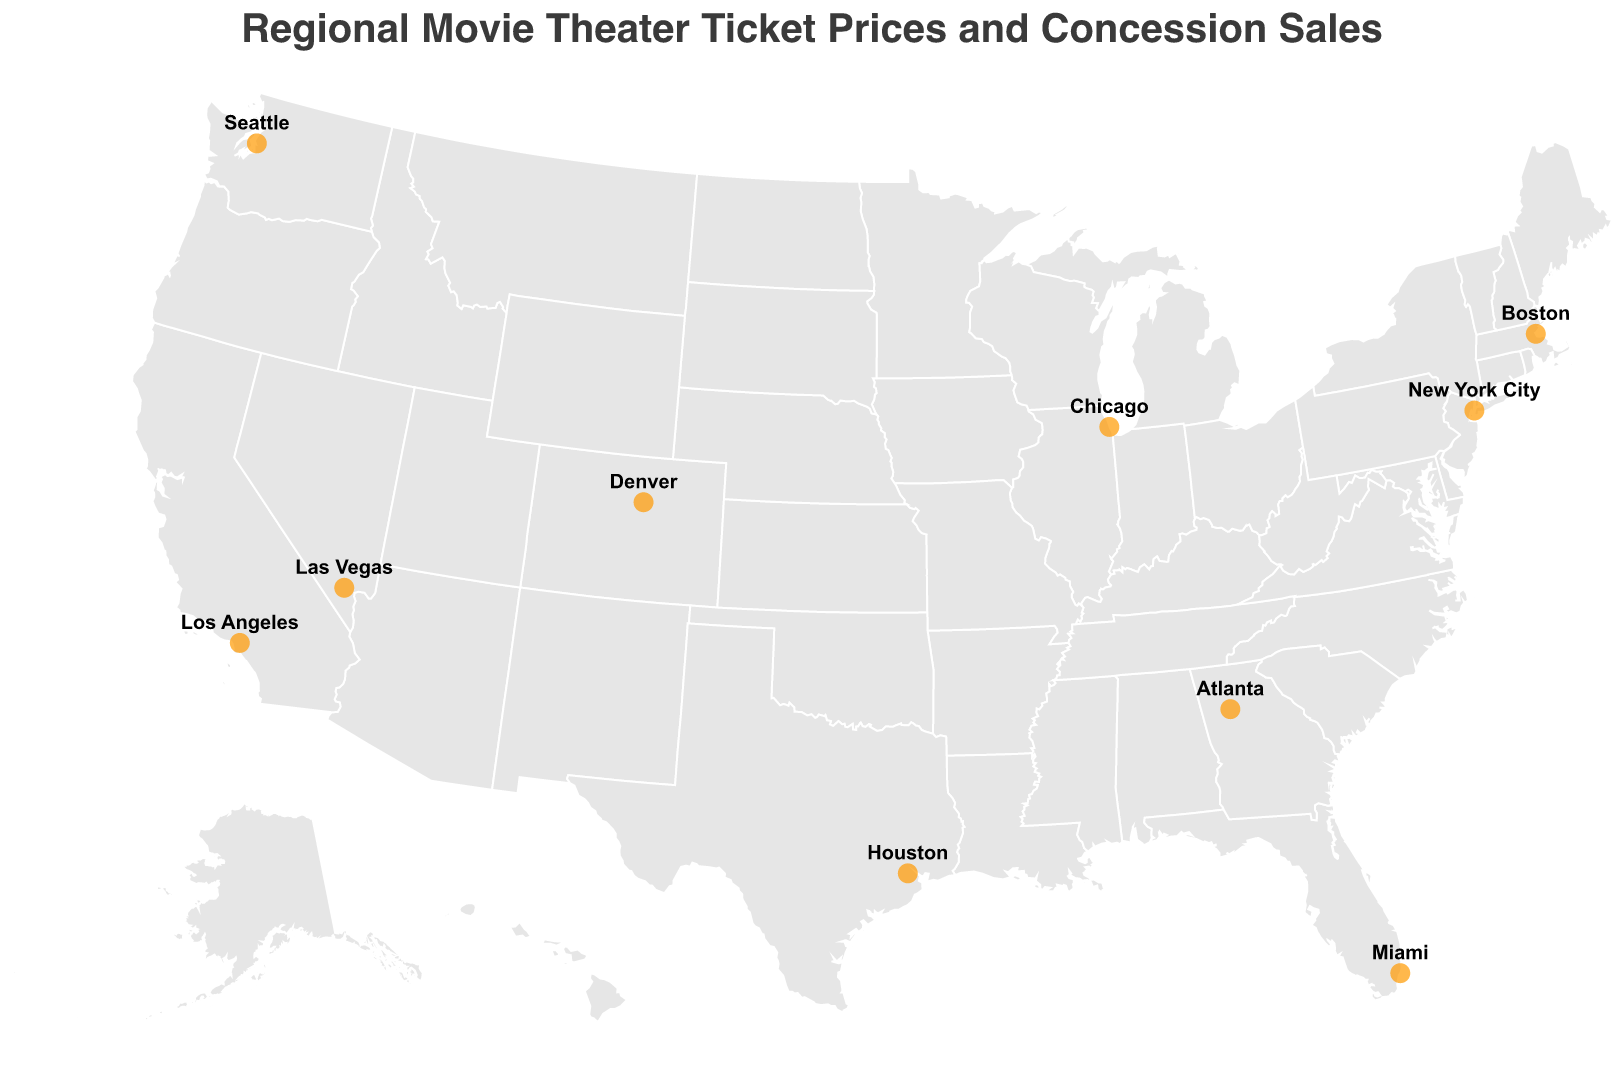What is the title of the figure? The title of the figure is usually displayed at the top in a larger and bolder font than the rest of the text. Here, it is a descriptive title summarizing the content of the plot.
Answer: Regional Movie Theater Ticket Prices and Concession Sales Which city has the highest ticket price? To find the city with the highest ticket price, look for the region with the largest numerical value in the "Ticket Price" tooltip.
Answer: New York City What is the most popular snack in Los Angeles? Check the region labeled "Los Angeles" and read the "Most Popular Snack" from its tooltip.
Answer: Nachos How do soda sales in Las Vegas compare to those in Seattle? Find the regions labeled "Las Vegas" and "Seattle" and compare their "Soda Sales" values from the tooltips. Las Vegas has 3300 soda sales, whereas Seattle has 2300.
Answer: Las Vegas has higher soda sales than Seattle Calculate the average ticket price for Atlanta, Denver, and Houston. Sum the ticket prices for these cities and divide by the number of cities to find the average. (11.25 + 12.50 + 11.50) / 3 = 35.25 / 3
Answer: 11.75 Which city has the lowest candy sales? Identify the city with the smallest numerical value in the "Candy Sales" field from the tooltips.
Answer: Denver Are there more cities with ticket prices above $14 or below $13? Count the cities whose ticket prices are above $14 and those below $13 by examining each region's tooltip. Above $14: New York City, Los Angeles, Boston. Below $13: Houston, Miami, Atlanta. There are 3 cities in both categories.
Answer: Equal number of cities in both categories What is the difference in popcorn sales between Miami and Boston? Subtract the popcorn sales value of Miami from that of Boston using their respective tooltips. 2900 - 2200 = 700
Answer: 700 Identify the city with the most diverse snacks (popcorn, soda, and candy sales are all within 500 of each other). Look for a city where the difference between the highest and lowest sales for popcorn, soda, and candy is within 500 by examining the tooltips. Miami: 2200, 2600, 2100 (range 500); fits the criteria.
Answer: Miami Which city has a higher soda sales-to-candy sales ratio, Chicago or Boston? Calculate the ratio by dividing the soda sales by candy sales for each city using their tooltips, then compare. Chicago: 2800 / 1700 ≈ 1.65, Boston: 2700 / 1800 = 1.5. Chicago has a higher ratio.
Answer: Chicago 